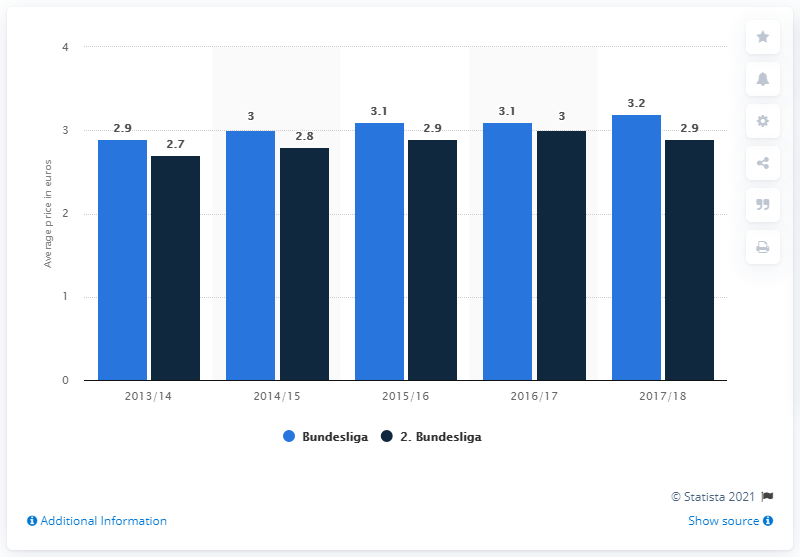Mention a couple of crucial points in this snapshot. The blue bar has the lowest value of 2.9. The sum of the highest and lowest values of the blue bar is 6.1. 